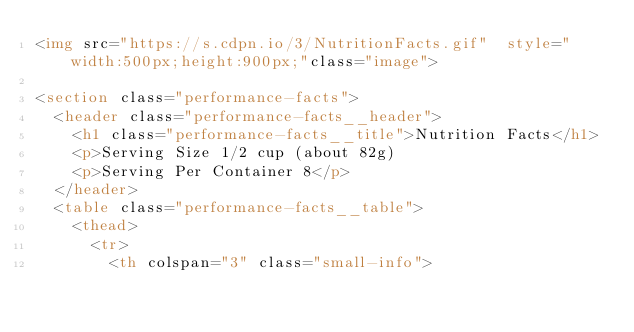Convert code to text. <code><loc_0><loc_0><loc_500><loc_500><_HTML_><img src="https://s.cdpn.io/3/NutritionFacts.gif"  style="width:500px;height:900px;"class="image">

<section class="performance-facts">
  <header class="performance-facts__header">
    <h1 class="performance-facts__title">Nutrition Facts</h1>
    <p>Serving Size 1/2 cup (about 82g)
    <p>Serving Per Container 8</p>
  </header>
  <table class="performance-facts__table">
    <thead>
      <tr>
        <th colspan="3" class="small-info"></code> 